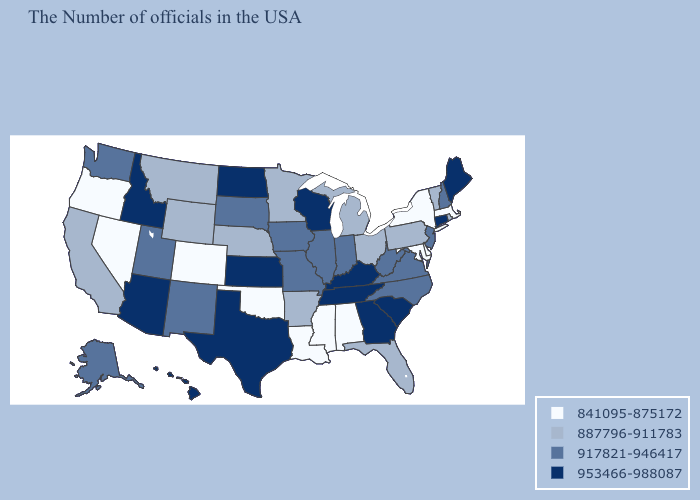What is the value of New Jersey?
Quick response, please. 917821-946417. Does Indiana have a lower value than Massachusetts?
Quick response, please. No. Name the states that have a value in the range 917821-946417?
Answer briefly. New Hampshire, New Jersey, Virginia, North Carolina, West Virginia, Indiana, Illinois, Missouri, Iowa, South Dakota, New Mexico, Utah, Washington, Alaska. What is the value of Oregon?
Answer briefly. 841095-875172. Does Michigan have the same value as Tennessee?
Give a very brief answer. No. Does Alabama have the lowest value in the USA?
Write a very short answer. Yes. Does Connecticut have a lower value than Idaho?
Keep it brief. No. Does Tennessee have the lowest value in the USA?
Keep it brief. No. What is the lowest value in the Northeast?
Be succinct. 841095-875172. What is the value of Oregon?
Quick response, please. 841095-875172. What is the value of Utah?
Answer briefly. 917821-946417. What is the value of Oklahoma?
Give a very brief answer. 841095-875172. What is the highest value in states that border Utah?
Write a very short answer. 953466-988087. 